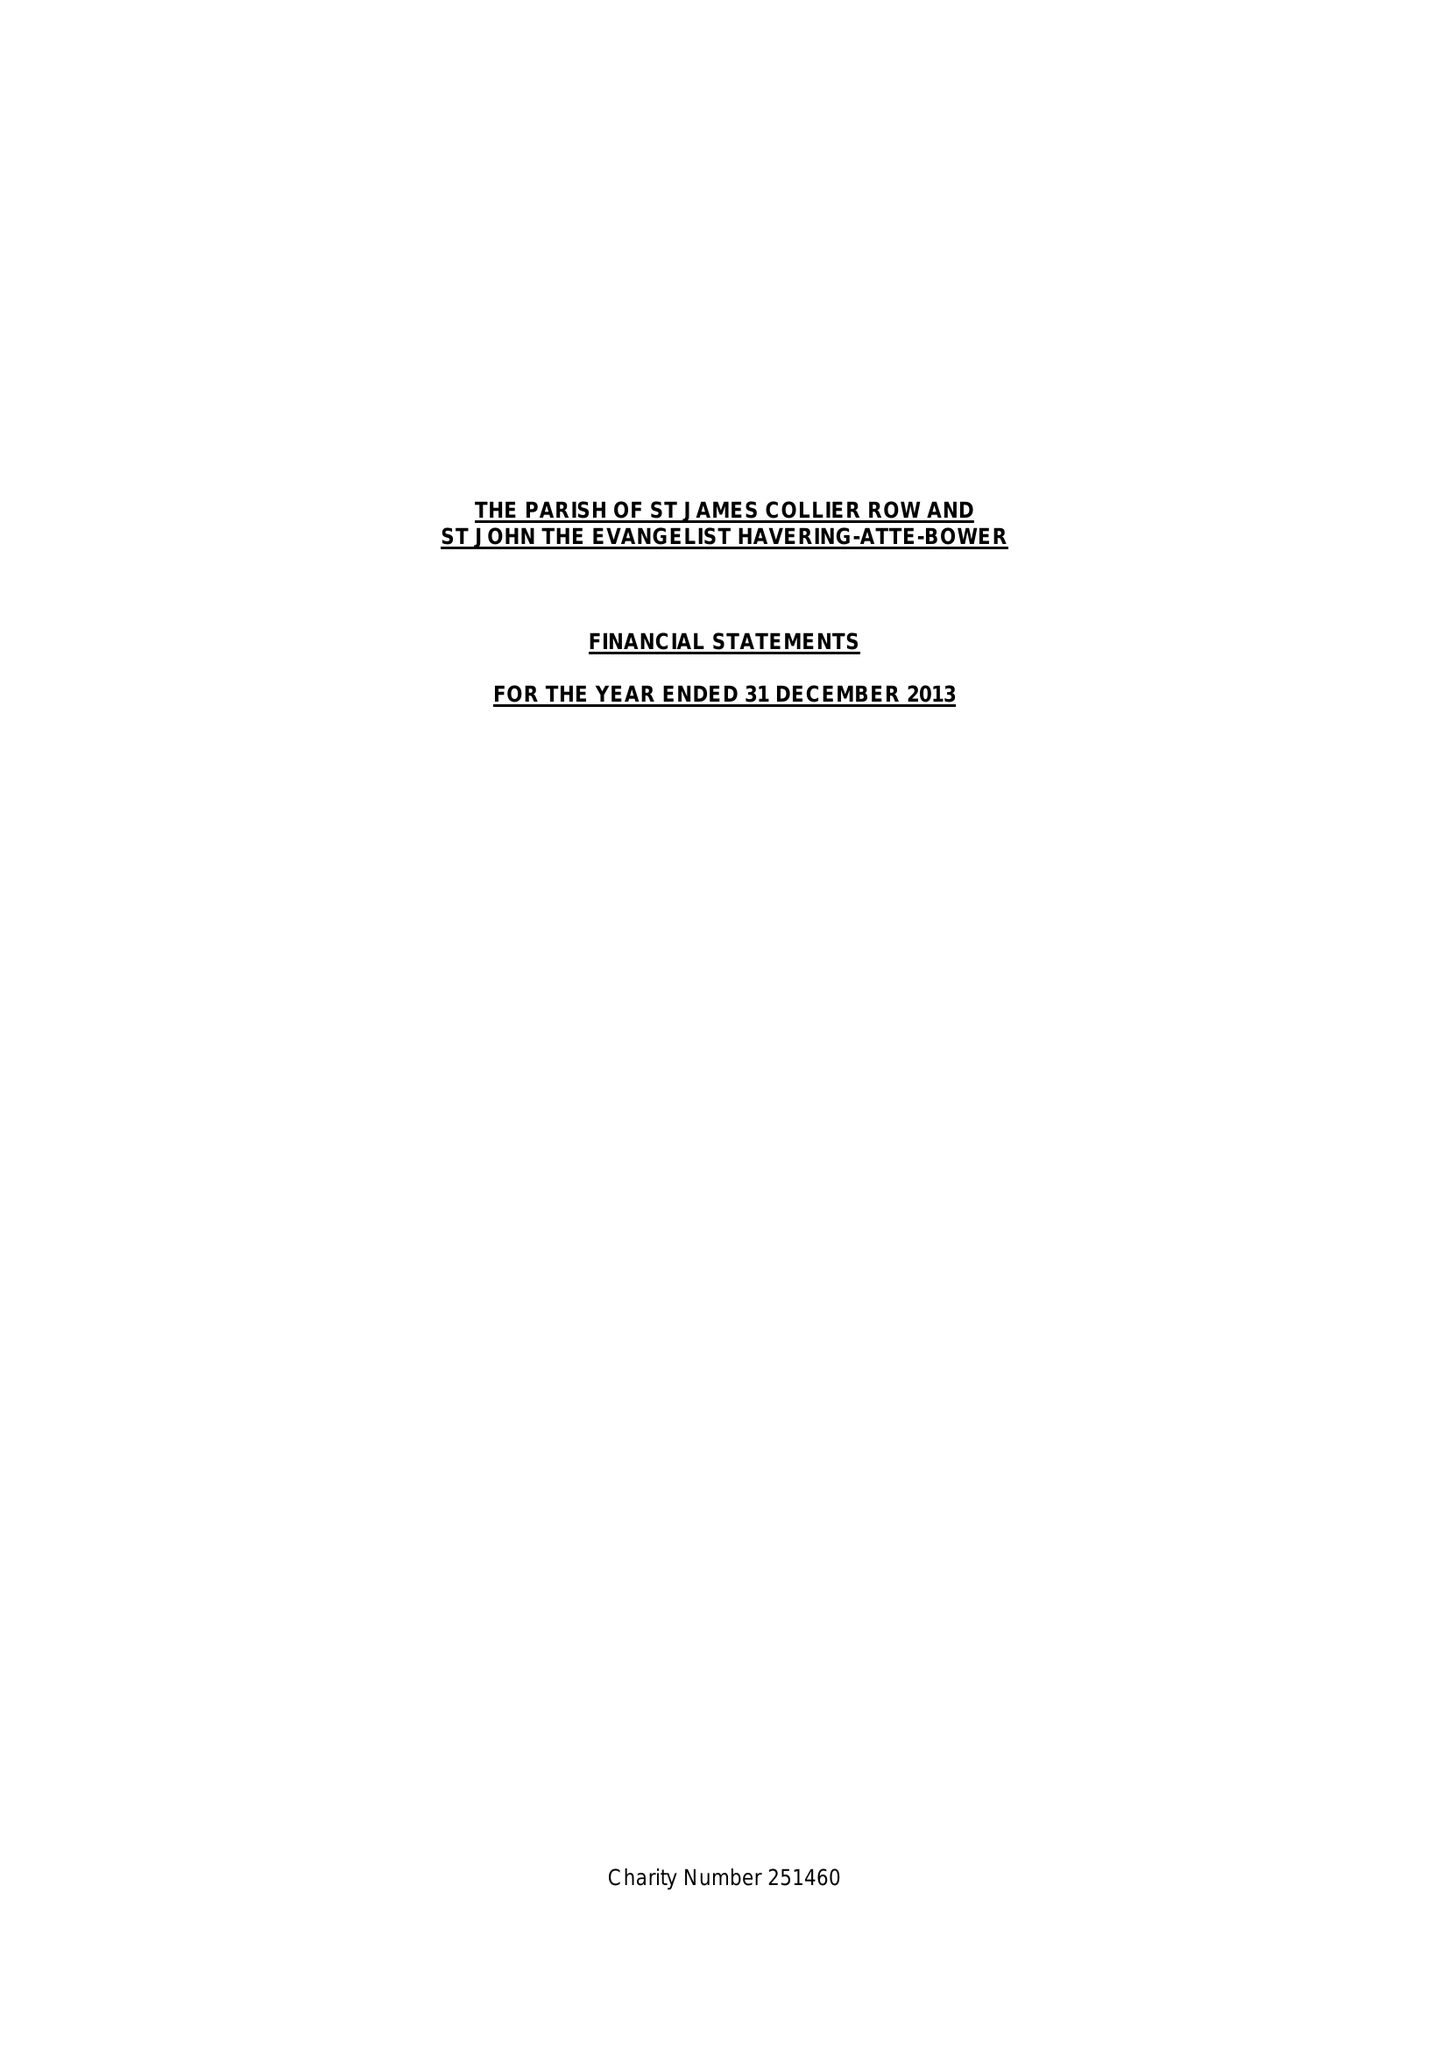What is the value for the income_annually_in_british_pounds?
Answer the question using a single word or phrase. 127168.00 